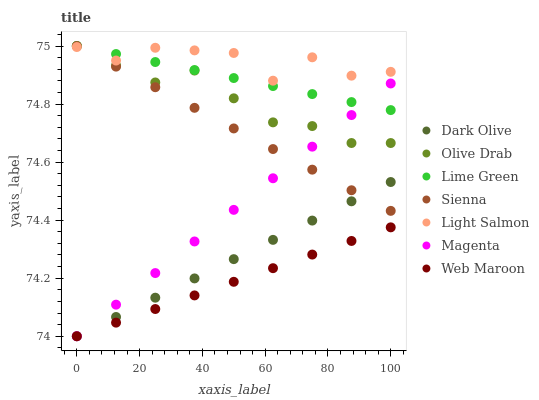Does Web Maroon have the minimum area under the curve?
Answer yes or no. Yes. Does Light Salmon have the maximum area under the curve?
Answer yes or no. Yes. Does Dark Olive have the minimum area under the curve?
Answer yes or no. No. Does Dark Olive have the maximum area under the curve?
Answer yes or no. No. Is Lime Green the smoothest?
Answer yes or no. Yes. Is Light Salmon the roughest?
Answer yes or no. Yes. Is Dark Olive the smoothest?
Answer yes or no. No. Is Dark Olive the roughest?
Answer yes or no. No. Does Dark Olive have the lowest value?
Answer yes or no. Yes. Does Sienna have the lowest value?
Answer yes or no. No. Does Olive Drab have the highest value?
Answer yes or no. Yes. Does Dark Olive have the highest value?
Answer yes or no. No. Is Web Maroon less than Sienna?
Answer yes or no. Yes. Is Light Salmon greater than Dark Olive?
Answer yes or no. Yes. Does Olive Drab intersect Magenta?
Answer yes or no. Yes. Is Olive Drab less than Magenta?
Answer yes or no. No. Is Olive Drab greater than Magenta?
Answer yes or no. No. Does Web Maroon intersect Sienna?
Answer yes or no. No. 